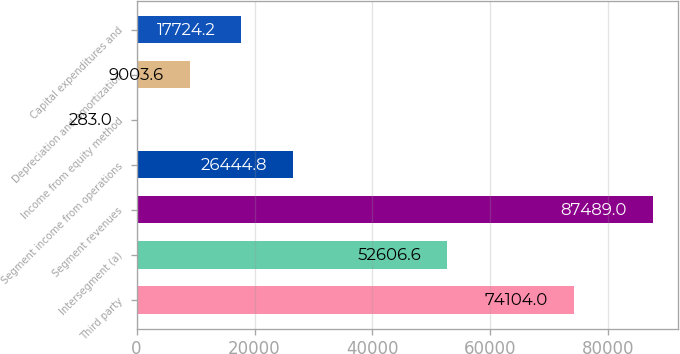Convert chart to OTSL. <chart><loc_0><loc_0><loc_500><loc_500><bar_chart><fcel>Third party<fcel>Intersegment (a)<fcel>Segment revenues<fcel>Segment income from operations<fcel>Income from equity method<fcel>Depreciation and amortization<fcel>Capital expenditures and<nl><fcel>74104<fcel>52606.6<fcel>87489<fcel>26444.8<fcel>283<fcel>9003.6<fcel>17724.2<nl></chart> 